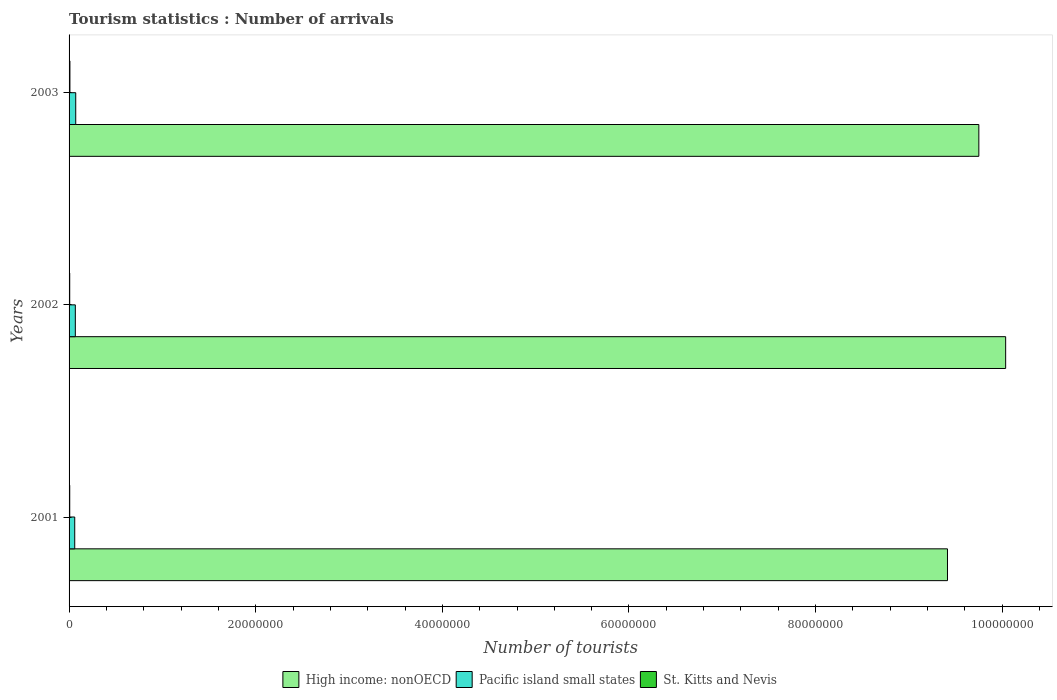How many different coloured bars are there?
Offer a very short reply. 3. Are the number of bars per tick equal to the number of legend labels?
Ensure brevity in your answer.  Yes. How many bars are there on the 2nd tick from the top?
Your answer should be very brief. 3. How many bars are there on the 2nd tick from the bottom?
Provide a succinct answer. 3. What is the label of the 2nd group of bars from the top?
Your response must be concise. 2002. In how many cases, is the number of bars for a given year not equal to the number of legend labels?
Provide a short and direct response. 0. What is the number of tourist arrivals in Pacific island small states in 2003?
Your response must be concise. 7.14e+05. Across all years, what is the maximum number of tourist arrivals in Pacific island small states?
Offer a terse response. 7.14e+05. Across all years, what is the minimum number of tourist arrivals in High income: nonOECD?
Give a very brief answer. 9.41e+07. What is the total number of tourist arrivals in High income: nonOECD in the graph?
Your answer should be compact. 2.92e+08. What is the difference between the number of tourist arrivals in High income: nonOECD in 2001 and that in 2002?
Provide a short and direct response. -6.23e+06. What is the difference between the number of tourist arrivals in High income: nonOECD in 2003 and the number of tourist arrivals in St. Kitts and Nevis in 2002?
Offer a very short reply. 9.74e+07. What is the average number of tourist arrivals in High income: nonOECD per year?
Offer a very short reply. 9.73e+07. In the year 2003, what is the difference between the number of tourist arrivals in High income: nonOECD and number of tourist arrivals in Pacific island small states?
Provide a short and direct response. 9.68e+07. What is the ratio of the number of tourist arrivals in St. Kitts and Nevis in 2002 to that in 2003?
Provide a succinct answer. 0.76. Is the number of tourist arrivals in St. Kitts and Nevis in 2002 less than that in 2003?
Provide a short and direct response. Yes. Is the difference between the number of tourist arrivals in High income: nonOECD in 2001 and 2003 greater than the difference between the number of tourist arrivals in Pacific island small states in 2001 and 2003?
Provide a short and direct response. No. What is the difference between the highest and the second highest number of tourist arrivals in St. Kitts and Nevis?
Give a very brief answer. 2.00e+04. What is the difference between the highest and the lowest number of tourist arrivals in St. Kitts and Nevis?
Provide a short and direct response. 2.20e+04. In how many years, is the number of tourist arrivals in High income: nonOECD greater than the average number of tourist arrivals in High income: nonOECD taken over all years?
Your answer should be compact. 2. What does the 1st bar from the top in 2002 represents?
Provide a short and direct response. St. Kitts and Nevis. What does the 3rd bar from the bottom in 2003 represents?
Provide a succinct answer. St. Kitts and Nevis. How many bars are there?
Provide a short and direct response. 9. Are all the bars in the graph horizontal?
Provide a short and direct response. Yes. Are the values on the major ticks of X-axis written in scientific E-notation?
Your response must be concise. No. Does the graph contain any zero values?
Your answer should be very brief. No. Does the graph contain grids?
Offer a terse response. No. Where does the legend appear in the graph?
Provide a succinct answer. Bottom center. How are the legend labels stacked?
Provide a succinct answer. Horizontal. What is the title of the graph?
Provide a short and direct response. Tourism statistics : Number of arrivals. What is the label or title of the X-axis?
Your response must be concise. Number of tourists. What is the Number of tourists of High income: nonOECD in 2001?
Offer a very short reply. 9.41e+07. What is the Number of tourists in Pacific island small states in 2001?
Your answer should be compact. 6.07e+05. What is the Number of tourists of St. Kitts and Nevis in 2001?
Offer a terse response. 7.10e+04. What is the Number of tourists in High income: nonOECD in 2002?
Make the answer very short. 1.00e+08. What is the Number of tourists of Pacific island small states in 2002?
Provide a short and direct response. 6.70e+05. What is the Number of tourists in St. Kitts and Nevis in 2002?
Offer a terse response. 6.90e+04. What is the Number of tourists in High income: nonOECD in 2003?
Keep it short and to the point. 9.75e+07. What is the Number of tourists of Pacific island small states in 2003?
Give a very brief answer. 7.14e+05. What is the Number of tourists of St. Kitts and Nevis in 2003?
Your answer should be compact. 9.10e+04. Across all years, what is the maximum Number of tourists of High income: nonOECD?
Your response must be concise. 1.00e+08. Across all years, what is the maximum Number of tourists in Pacific island small states?
Keep it short and to the point. 7.14e+05. Across all years, what is the maximum Number of tourists of St. Kitts and Nevis?
Offer a terse response. 9.10e+04. Across all years, what is the minimum Number of tourists of High income: nonOECD?
Your answer should be very brief. 9.41e+07. Across all years, what is the minimum Number of tourists in Pacific island small states?
Your answer should be compact. 6.07e+05. Across all years, what is the minimum Number of tourists in St. Kitts and Nevis?
Keep it short and to the point. 6.90e+04. What is the total Number of tourists in High income: nonOECD in the graph?
Provide a succinct answer. 2.92e+08. What is the total Number of tourists in Pacific island small states in the graph?
Make the answer very short. 1.99e+06. What is the total Number of tourists in St. Kitts and Nevis in the graph?
Provide a short and direct response. 2.31e+05. What is the difference between the Number of tourists in High income: nonOECD in 2001 and that in 2002?
Your answer should be very brief. -6.23e+06. What is the difference between the Number of tourists of Pacific island small states in 2001 and that in 2002?
Ensure brevity in your answer.  -6.31e+04. What is the difference between the Number of tourists of High income: nonOECD in 2001 and that in 2003?
Your response must be concise. -3.36e+06. What is the difference between the Number of tourists of Pacific island small states in 2001 and that in 2003?
Offer a terse response. -1.08e+05. What is the difference between the Number of tourists in St. Kitts and Nevis in 2001 and that in 2003?
Offer a very short reply. -2.00e+04. What is the difference between the Number of tourists of High income: nonOECD in 2002 and that in 2003?
Offer a very short reply. 2.87e+06. What is the difference between the Number of tourists in Pacific island small states in 2002 and that in 2003?
Offer a terse response. -4.45e+04. What is the difference between the Number of tourists of St. Kitts and Nevis in 2002 and that in 2003?
Give a very brief answer. -2.20e+04. What is the difference between the Number of tourists in High income: nonOECD in 2001 and the Number of tourists in Pacific island small states in 2002?
Offer a terse response. 9.35e+07. What is the difference between the Number of tourists of High income: nonOECD in 2001 and the Number of tourists of St. Kitts and Nevis in 2002?
Make the answer very short. 9.41e+07. What is the difference between the Number of tourists in Pacific island small states in 2001 and the Number of tourists in St. Kitts and Nevis in 2002?
Offer a terse response. 5.38e+05. What is the difference between the Number of tourists in High income: nonOECD in 2001 and the Number of tourists in Pacific island small states in 2003?
Your answer should be very brief. 9.34e+07. What is the difference between the Number of tourists in High income: nonOECD in 2001 and the Number of tourists in St. Kitts and Nevis in 2003?
Provide a succinct answer. 9.40e+07. What is the difference between the Number of tourists in Pacific island small states in 2001 and the Number of tourists in St. Kitts and Nevis in 2003?
Give a very brief answer. 5.16e+05. What is the difference between the Number of tourists of High income: nonOECD in 2002 and the Number of tourists of Pacific island small states in 2003?
Provide a succinct answer. 9.97e+07. What is the difference between the Number of tourists of High income: nonOECD in 2002 and the Number of tourists of St. Kitts and Nevis in 2003?
Provide a succinct answer. 1.00e+08. What is the difference between the Number of tourists in Pacific island small states in 2002 and the Number of tourists in St. Kitts and Nevis in 2003?
Give a very brief answer. 5.79e+05. What is the average Number of tourists in High income: nonOECD per year?
Provide a short and direct response. 9.73e+07. What is the average Number of tourists in Pacific island small states per year?
Your response must be concise. 6.64e+05. What is the average Number of tourists in St. Kitts and Nevis per year?
Make the answer very short. 7.70e+04. In the year 2001, what is the difference between the Number of tourists in High income: nonOECD and Number of tourists in Pacific island small states?
Offer a very short reply. 9.35e+07. In the year 2001, what is the difference between the Number of tourists in High income: nonOECD and Number of tourists in St. Kitts and Nevis?
Your answer should be compact. 9.41e+07. In the year 2001, what is the difference between the Number of tourists in Pacific island small states and Number of tourists in St. Kitts and Nevis?
Your response must be concise. 5.36e+05. In the year 2002, what is the difference between the Number of tourists of High income: nonOECD and Number of tourists of Pacific island small states?
Keep it short and to the point. 9.97e+07. In the year 2002, what is the difference between the Number of tourists of High income: nonOECD and Number of tourists of St. Kitts and Nevis?
Provide a short and direct response. 1.00e+08. In the year 2002, what is the difference between the Number of tourists in Pacific island small states and Number of tourists in St. Kitts and Nevis?
Your response must be concise. 6.01e+05. In the year 2003, what is the difference between the Number of tourists of High income: nonOECD and Number of tourists of Pacific island small states?
Offer a very short reply. 9.68e+07. In the year 2003, what is the difference between the Number of tourists in High income: nonOECD and Number of tourists in St. Kitts and Nevis?
Your response must be concise. 9.74e+07. In the year 2003, what is the difference between the Number of tourists of Pacific island small states and Number of tourists of St. Kitts and Nevis?
Offer a terse response. 6.23e+05. What is the ratio of the Number of tourists in High income: nonOECD in 2001 to that in 2002?
Your response must be concise. 0.94. What is the ratio of the Number of tourists in Pacific island small states in 2001 to that in 2002?
Give a very brief answer. 0.91. What is the ratio of the Number of tourists in St. Kitts and Nevis in 2001 to that in 2002?
Ensure brevity in your answer.  1.03. What is the ratio of the Number of tourists of High income: nonOECD in 2001 to that in 2003?
Provide a short and direct response. 0.97. What is the ratio of the Number of tourists in Pacific island small states in 2001 to that in 2003?
Keep it short and to the point. 0.85. What is the ratio of the Number of tourists of St. Kitts and Nevis in 2001 to that in 2003?
Provide a short and direct response. 0.78. What is the ratio of the Number of tourists in High income: nonOECD in 2002 to that in 2003?
Your answer should be compact. 1.03. What is the ratio of the Number of tourists in Pacific island small states in 2002 to that in 2003?
Offer a terse response. 0.94. What is the ratio of the Number of tourists of St. Kitts and Nevis in 2002 to that in 2003?
Provide a short and direct response. 0.76. What is the difference between the highest and the second highest Number of tourists in High income: nonOECD?
Make the answer very short. 2.87e+06. What is the difference between the highest and the second highest Number of tourists of Pacific island small states?
Your answer should be very brief. 4.45e+04. What is the difference between the highest and the lowest Number of tourists in High income: nonOECD?
Offer a very short reply. 6.23e+06. What is the difference between the highest and the lowest Number of tourists in Pacific island small states?
Provide a succinct answer. 1.08e+05. What is the difference between the highest and the lowest Number of tourists in St. Kitts and Nevis?
Make the answer very short. 2.20e+04. 